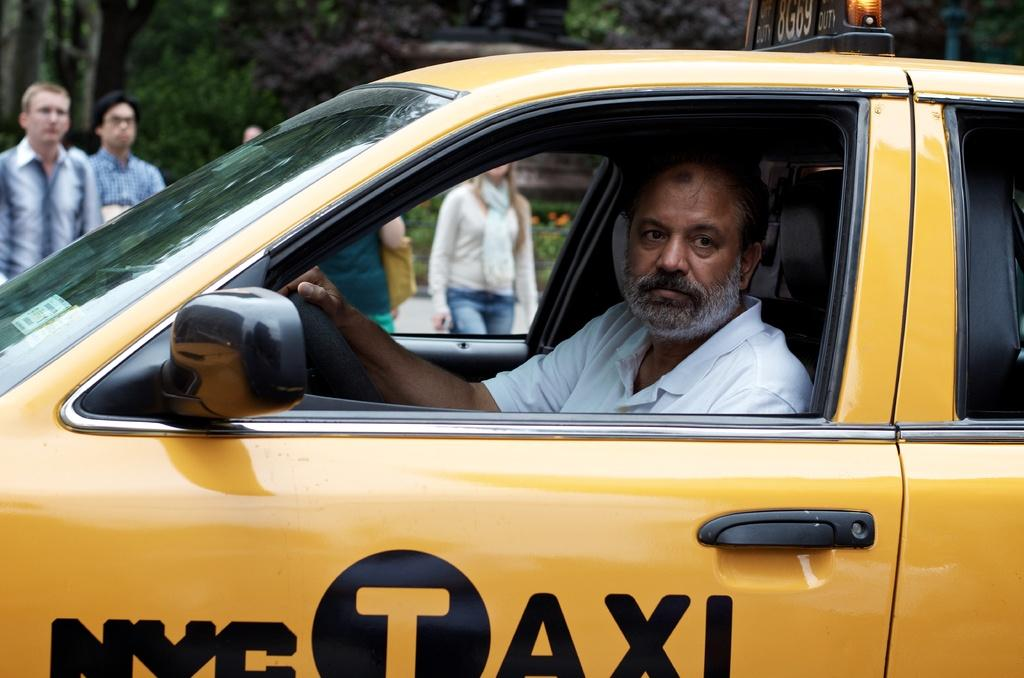Provide a one-sentence caption for the provided image. a man wearing a yellow shirt while riding a yellow taxi cab with the nyc logo on the bottom. 